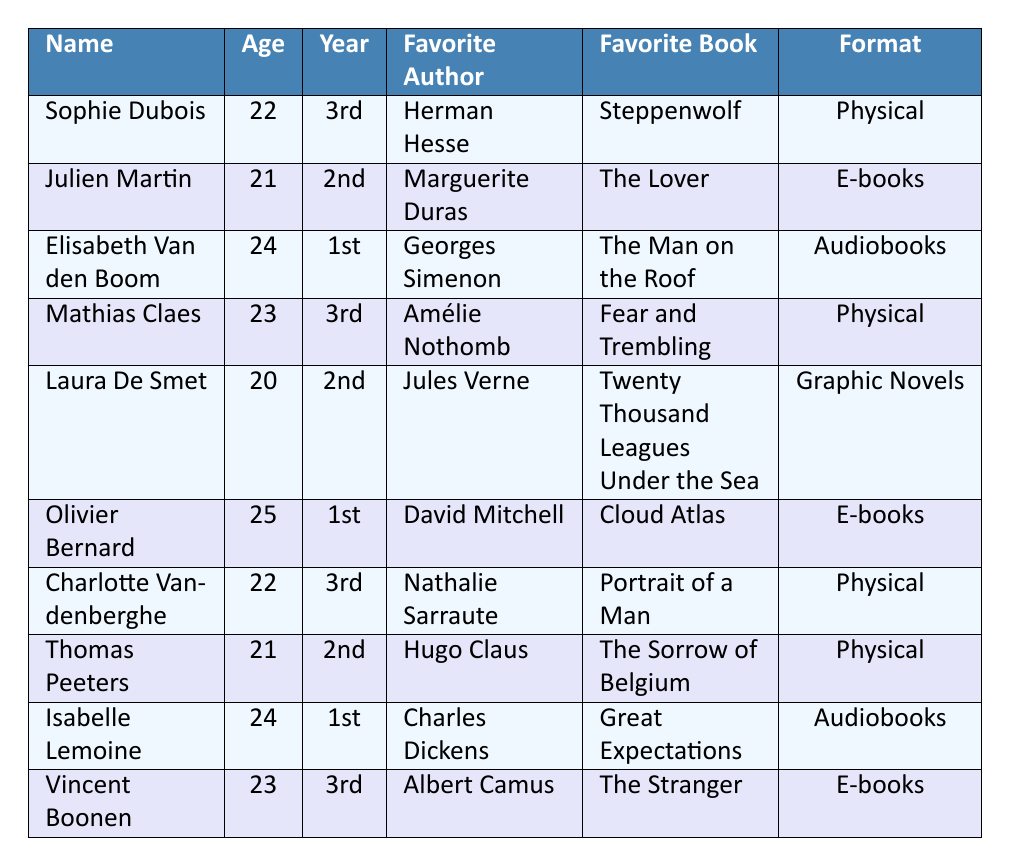What is the favorite book of Sophie Dubois? Sophie Dubois is listed in the table, and her favorite book is noted as "Steppenwolf."
Answer: Steppenwolf How many students prefer physical books as their reading format? By reviewing the table, I can count the instances of "Physical" in the reading format column, which appears 5 times.
Answer: 5 Who is the oldest student and what is their age? The ages of the students are listed, and by comparing them, I see that Olivier Bernard is the oldest at 25 years old.
Answer: 25 What are the preferred genres of Laura De Smet? I can directly refer to the entry for Laura De Smet; her preferred genres are "Adventure" and "Science Fiction."
Answer: Adventure, Science Fiction Is there a student who prefers audiobooks? I will check each student’s reading format and find that both Elisabeth Van den Boom and Isabelle Lemoine prefer audiobooks, therefore the answer is yes.
Answer: Yes How many students are in their 1st year? By going through the academic year column, I can see that 3 students (Elisabeth Van den Boom, Olivier Bernard, Isabelle Lemoine) are in their 1st year.
Answer: 3 Which student has the favorite author "Albert Camus"? I will look through the table for the favorite author column and find that Vincent Boonen has "Albert Camus" as his favorite author.
Answer: Vincent Boonen What is the average reading frequency of the students? Calculating the frequency values: 3 + 2 + 5 + 2 + 4 + 2 + 3 + 1 + 4 + 2 gives 28. Since there are 10 students, the average is 28 / 10 = 2.8 books per month.
Answer: 2.8 books per month Which genres are preferred by students who enjoy "Psychological" literature? Only Sophie Dubois mentions "Psychological" as a preferred genre, identifying her interest specifically in that genre.
Answer: Fiction, Psychological Does any student have "Georges Simenon" as their favorite author? Upon inspection of the table, I see that Elisabeth Van den Boom lists "Georges Simenon" as her favorite author, confirming the fact's validity.
Answer: Yes How many students read more than 4 books per month? From the reading frequency column, I identify that 2 students (Elisabeth Van den Boom and Isabelle Lemoine) read more than 4 books per month.
Answer: 2 What patterns can be drawn about the reading formats among 3rd-year students? By filtering the table to only show 3rd-year students, I notice they read physical books and e-books but no audiobooks, showing a preference for physical formats.
Answer: They prefer physical books and e-books 